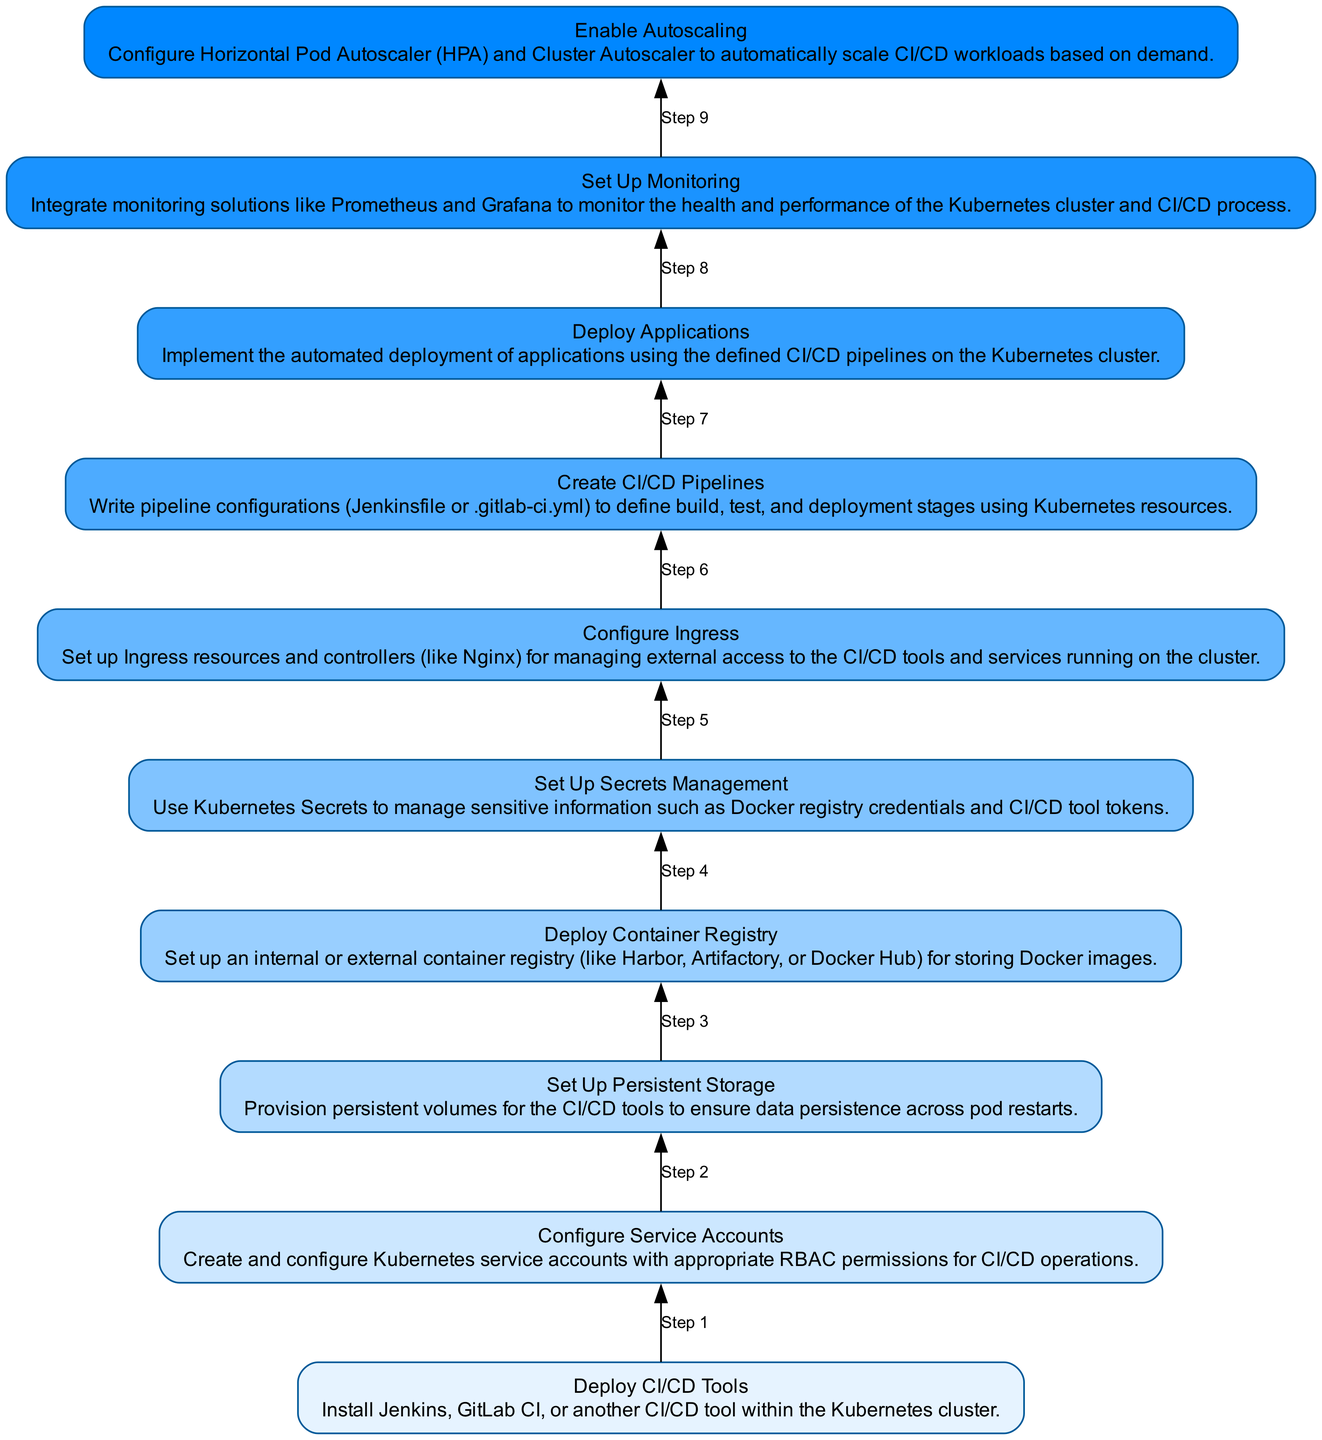What do you need to deploy within the Kubernetes cluster for CI/CD? The diagram specifies that you need to "Deploy CI/CD Tools" such as Jenkins or GitLab CI, indicating that this is a foundational step in the flowchart.
Answer: Deploy CI/CD Tools What is created to grant the necessary permissions for CI/CD operations? The flowchart shows that "Configure Service Accounts" is a step where Kubernetes service accounts with RBAC permissions are created, meaning this is the step that directly addresses permissions.
Answer: Configure Service Accounts How many primary steps are outlined in the flowchart? By counting the nodes in the diagram, I see that there are ten distinct steps listed, which represent the primary actions to be taken in the setup process.
Answer: Ten Which step follows after setting up persistent storage? Looking at the flow from bottom to top, the step that follows "Set Up Persistent Storage" is "Deploy Container Registry", indicating the next logical action in the process.
Answer: Deploy Container Registry What is the role of Kubernetes Secrets in this flowchart? The diagram includes "Set Up Secrets Management", indicating that Secrets are used to manage sensitive information, highlighting that this is a specific action outlined in the process.
Answer: Manage sensitive information What needs to be defined to automate application deployments? The diagram details "Create CI/CD Pipelines" as the step where pipeline configurations, such as Jenkinsfile or .gitlab-ci.yml, are written, establishing what needs to be defined for automation.
Answer: CI/CD Pipelines Which step is related to the external access setup for CI/CD tools? The diagram points to "Configure Ingress", which is specifically about managing external access, highlighting the importance of this step for connectivity.
Answer: Configure Ingress What is the critical element that ensures data persistence across pod restarts? From the flowchart, "Set Up Persistent Storage" is highlighted as the step that involves provisioning persistent volumes, directly indicating its role in data persistence.
Answer: Persistent Storage Which action involves monitoring the health of the Kubernetes cluster? The diagram lists "Set Up Monitoring" as the process to integrate monitoring solutions like Prometheus and Grafana, making it clear that this step is essential for health checks.
Answer: Set Up Monitoring What helps to automatically scale CI/CD workloads in the cluster? The diagram specifies "Enable Autoscaling" as a step to configure Horizontal Pod Autoscaler and Cluster Autoscaler, indicating this is the method for scaling workloads automatically.
Answer: Enable Autoscaling 